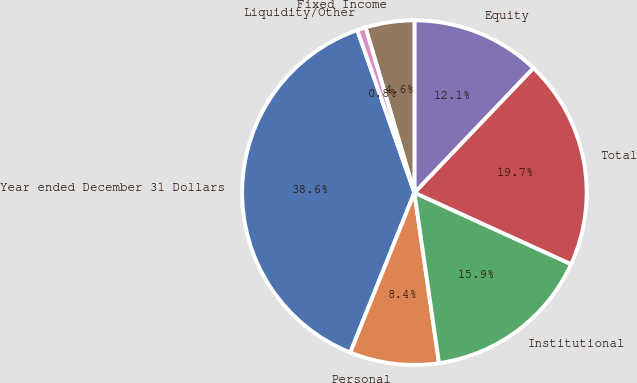<chart> <loc_0><loc_0><loc_500><loc_500><pie_chart><fcel>Year ended December 31 Dollars<fcel>Personal<fcel>Institutional<fcel>Total<fcel>Equity<fcel>Fixed Income<fcel>Liquidity/Other<nl><fcel>38.55%<fcel>8.35%<fcel>15.9%<fcel>19.68%<fcel>12.13%<fcel>4.58%<fcel>0.8%<nl></chart> 